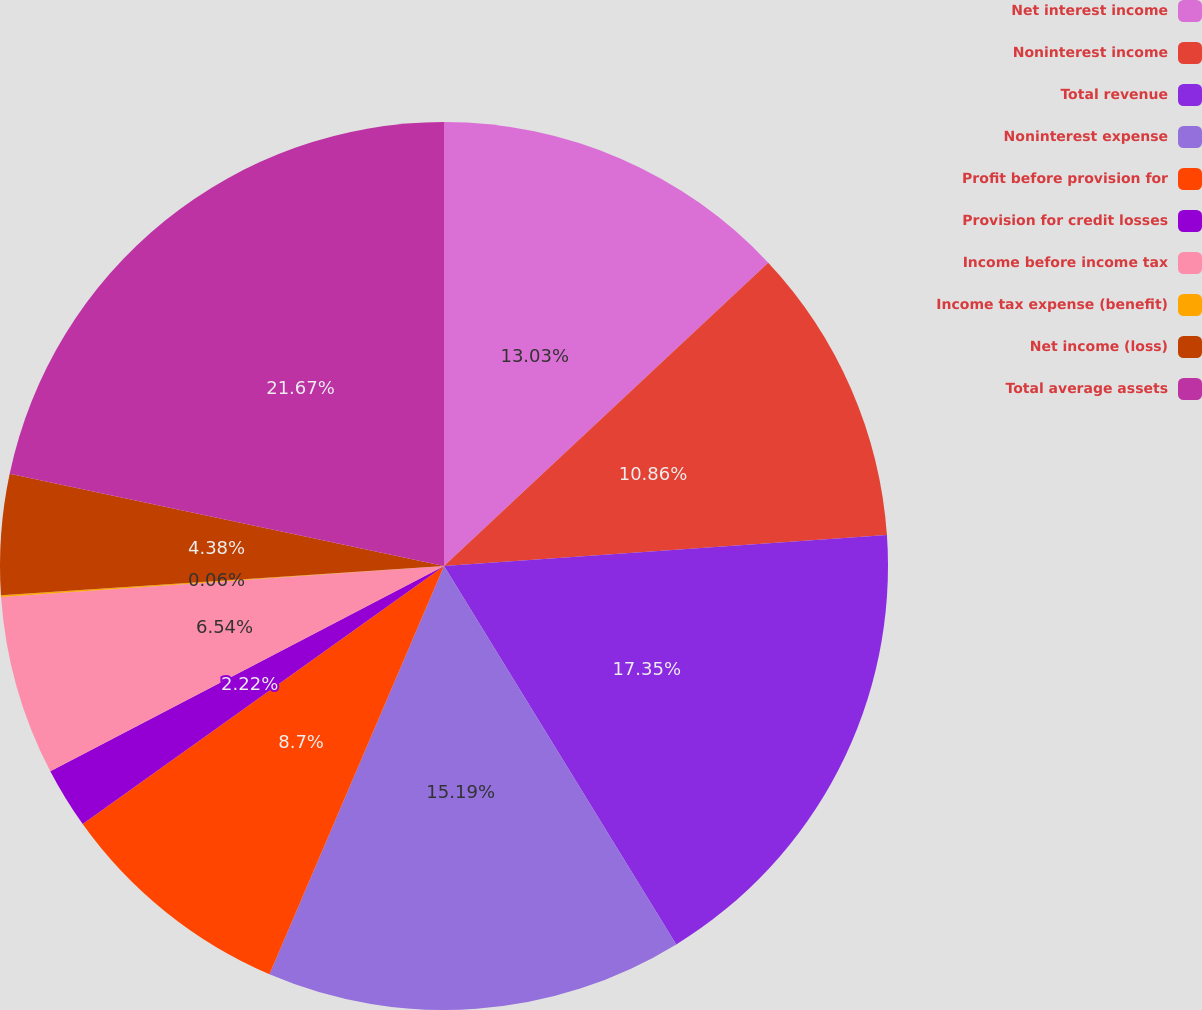Convert chart. <chart><loc_0><loc_0><loc_500><loc_500><pie_chart><fcel>Net interest income<fcel>Noninterest income<fcel>Total revenue<fcel>Noninterest expense<fcel>Profit before provision for<fcel>Provision for credit losses<fcel>Income before income tax<fcel>Income tax expense (benefit)<fcel>Net income (loss)<fcel>Total average assets<nl><fcel>13.03%<fcel>10.86%<fcel>17.35%<fcel>15.19%<fcel>8.7%<fcel>2.22%<fcel>6.54%<fcel>0.06%<fcel>4.38%<fcel>21.67%<nl></chart> 